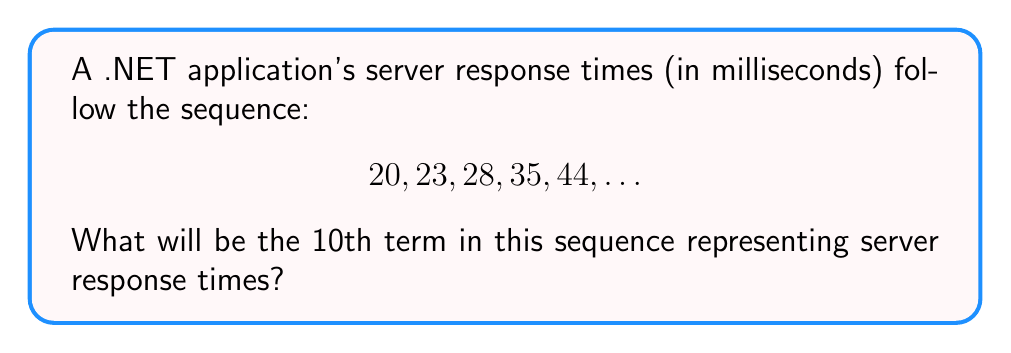Help me with this question. To solve this problem, let's follow these steps:

1) First, let's examine the differences between consecutive terms:
   20 to 23: +3
   23 to 28: +5
   28 to 35: +7
   35 to 44: +9

2) We can see that the differences are increasing by 2 each time: 3, 5, 7, 9, ...

3) This suggests that our sequence is a quadratic sequence, where the second differences are constant.

4) The general form of a quadratic sequence is:
   $$a_n = an^2 + bn + c$$
   where $a_n$ is the nth term, and $a$, $b$, and $c$ are constants.

5) To find $a$, $b$, and $c$, we can use the first three terms:
   $$20 = a(1)^2 + b(1) + c$$
   $$23 = a(2)^2 + b(2) + c$$
   $$28 = a(3)^2 + b(3) + c$$

6) Subtracting the first equation from the second:
   $$3 = 3a + b$$

7) Subtracting the second equation from the third:
   $$5 = 5a + b$$

8) Subtracting these two new equations:
   $$2 = 2a$$
   $$a = 1$$

9) Substituting back:
   $$3 = 3(1) + b$$
   $$b = 0$$

10) Using the first equation:
    $$20 = 1 + 0 + c$$
    $$c = 19$$

11) Therefore, our sequence follows the formula:
    $$a_n = n^2 + 19$$

12) To find the 10th term, we substitute $n = 10$:
    $$a_{10} = 10^2 + 19 = 100 + 19 = 119$$
Answer: 119 ms 